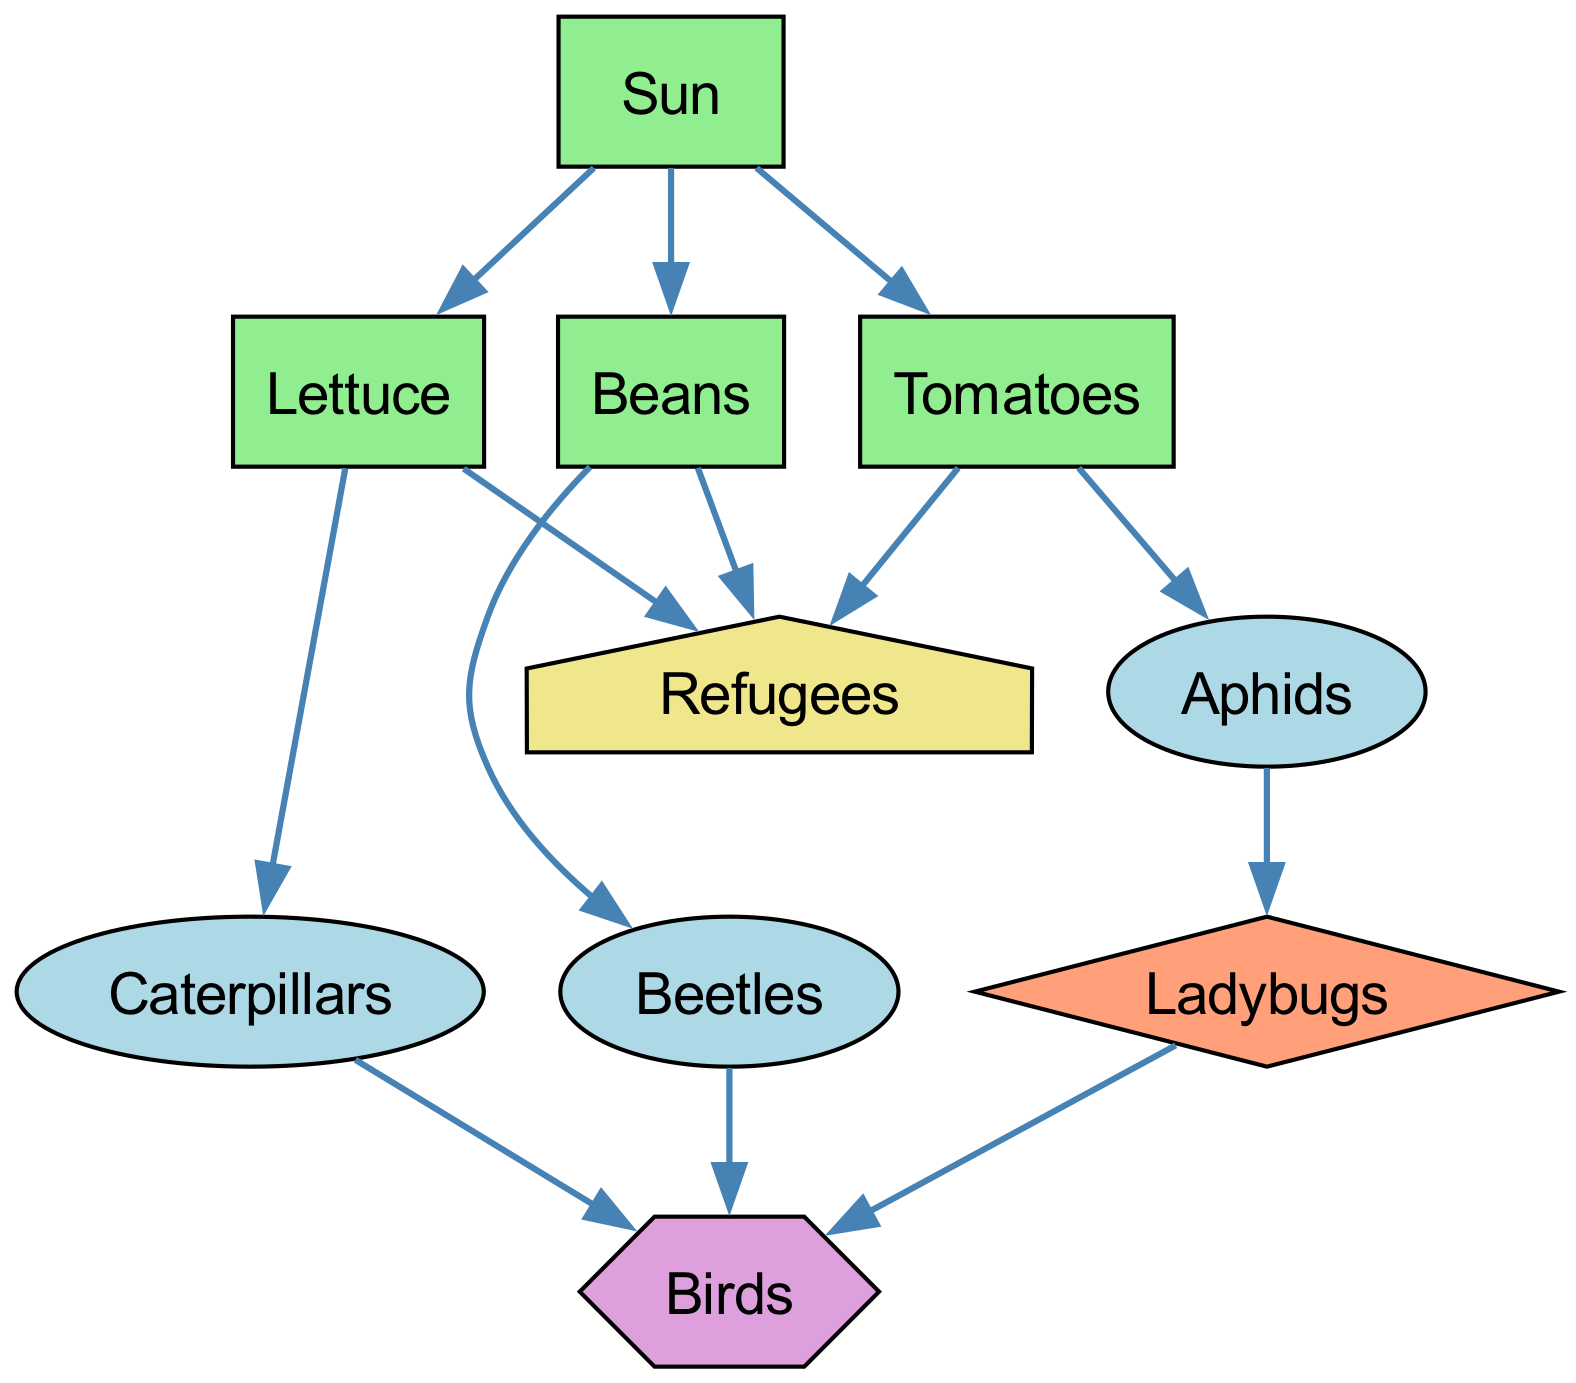What is the type of "Tomatoes"? The diagram indicates that "Tomatoes" are classified as a "producer" since it converts sunlight into food through photosynthesis.
Answer: producer How many primary consumers are there in the diagram? By counting the elements categorized as "primary consumer," we identify three: "Aphids," "Caterpillars," and "Beetles."
Answer: 3 Who do "Beetles" connect to? "Beetles" uniquely connect to "Birds" as per the data provided in the connections for "Beetles."
Answer: Birds Which element is the top of the food chain? The "Birds" are at the top of the food chain in this diagram as they are labeled as tertiary consumers and do not have any connections going out to other consumers.
Answer: Birds How many producers are there in total? The diagram reveals four producers: "Tomatoes," "Lettuce," "Beans," and "Sun," signifying the beginning of the food chain.
Answer: 4 Which insect is a secondary consumer? From the data shared in the diagram, "Ladybugs" are specifically noted as a secondary consumer that preys on "Aphids."
Answer: Ladybugs What connects "Refugees" to the food chain? The "Refugees" connection is indicated at the end of the chain, where it receives sustenance or produce from "Tomatoes," "Lettuce," and "Beans."
Answer: Tomatoes, Lettuce, Beans What role does "Sun" play in this food chain? In this ecological context, the "Sun" serves as a producer, as it provides energy essential for photosynthesis, supporting plant growth and thus initiating the food chain.
Answer: producer Are there any tertiary consumers present? The diagram labels "Birds" as the only tertiary consumer, illustrating their position in the food chain as higher-level consumers.
Answer: Birds 